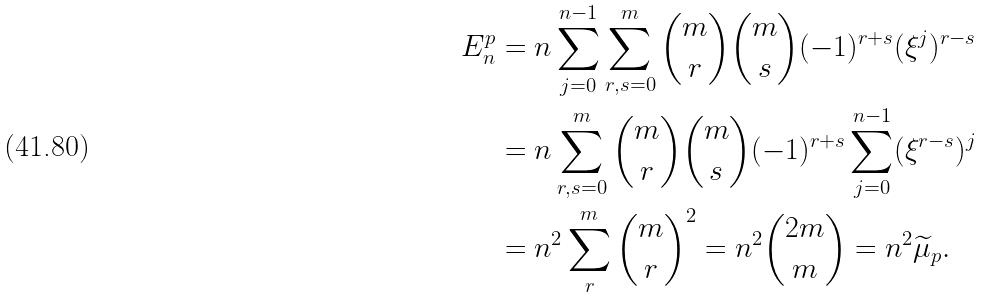<formula> <loc_0><loc_0><loc_500><loc_500>E _ { n } ^ { p } & = n \sum _ { j = 0 } ^ { n - 1 } \sum _ { r , s = 0 } ^ { m } \binom { m } { r } \binom { m } { s } ( - 1 ) ^ { r + s } ( \xi ^ { j } ) ^ { r - s } \\ & = n \sum _ { r , s = 0 } ^ { m } \binom { m } { r } \binom { m } { s } ( - 1 ) ^ { r + s } \sum _ { j = 0 } ^ { n - 1 } ( \xi ^ { r - s } ) ^ { j } \\ & = n ^ { 2 } \sum _ { r } ^ { m } \binom { m } { r } ^ { 2 } = n ^ { 2 } \binom { 2 m } { m } = n ^ { 2 } \widetilde { \mu } _ { p } .</formula> 